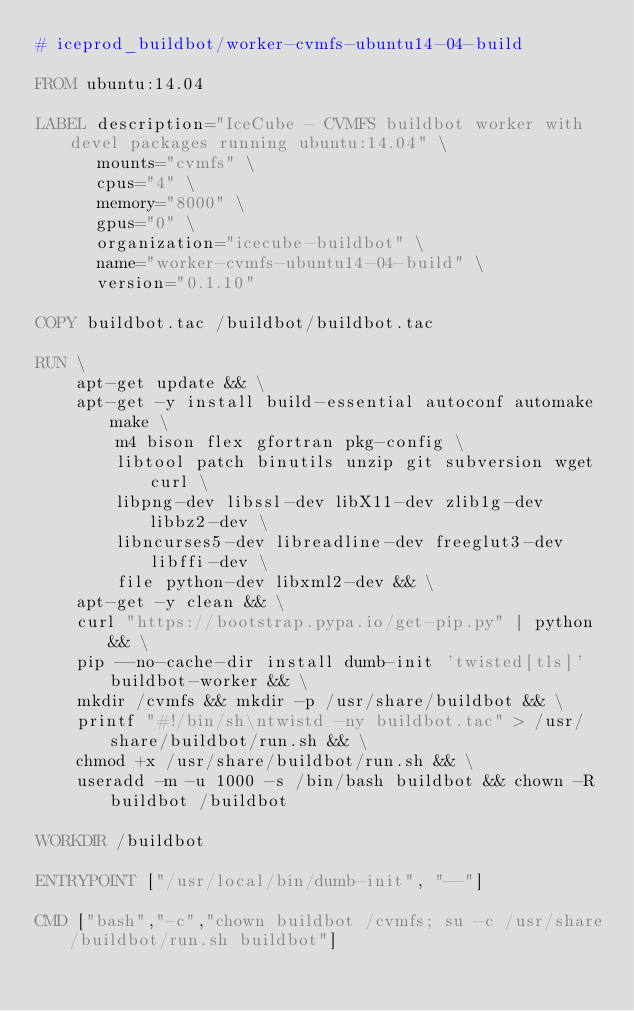<code> <loc_0><loc_0><loc_500><loc_500><_Dockerfile_># iceprod_buildbot/worker-cvmfs-ubuntu14-04-build

FROM ubuntu:14.04

LABEL description="IceCube - CVMFS buildbot worker with devel packages running ubuntu:14.04" \
      mounts="cvmfs" \
      cpus="4" \
      memory="8000" \
      gpus="0" \
      organization="icecube-buildbot" \
      name="worker-cvmfs-ubuntu14-04-build" \
      version="0.1.10"

COPY buildbot.tac /buildbot/buildbot.tac

RUN \
    apt-get update && \
    apt-get -y install build-essential autoconf automake make \
        m4 bison flex gfortran pkg-config \
        libtool patch binutils unzip git subversion wget curl \
        libpng-dev libssl-dev libX11-dev zlib1g-dev libbz2-dev \
        libncurses5-dev libreadline-dev freeglut3-dev libffi-dev \
        file python-dev libxml2-dev && \
    apt-get -y clean && \
    curl "https://bootstrap.pypa.io/get-pip.py" | python && \
    pip --no-cache-dir install dumb-init 'twisted[tls]' buildbot-worker && \
    mkdir /cvmfs && mkdir -p /usr/share/buildbot && \
    printf "#!/bin/sh\ntwistd -ny buildbot.tac" > /usr/share/buildbot/run.sh && \
    chmod +x /usr/share/buildbot/run.sh && \
    useradd -m -u 1000 -s /bin/bash buildbot && chown -R buildbot /buildbot

WORKDIR /buildbot

ENTRYPOINT ["/usr/local/bin/dumb-init", "--"]

CMD ["bash","-c","chown buildbot /cvmfs; su -c /usr/share/buildbot/run.sh buildbot"]
</code> 